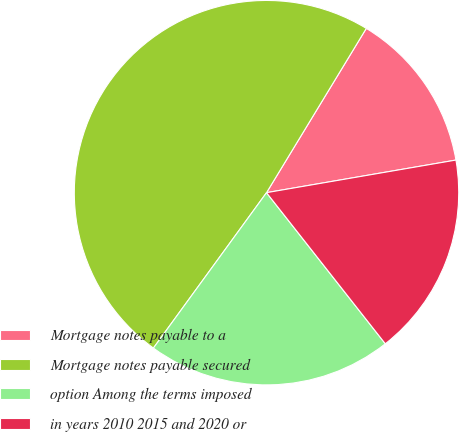<chart> <loc_0><loc_0><loc_500><loc_500><pie_chart><fcel>Mortgage notes payable to a<fcel>Mortgage notes payable secured<fcel>option Among the terms imposed<fcel>in years 2010 2015 and 2020 or<nl><fcel>13.6%<fcel>48.68%<fcel>20.62%<fcel>17.11%<nl></chart> 